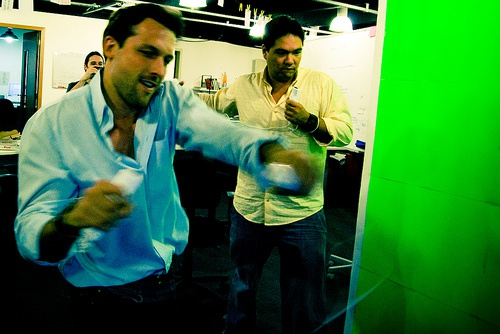Describe the objects in this image and their specific colors. I can see people in black, lightgreen, and teal tones, people in black, khaki, and olive tones, remote in black, beige, and teal tones, remote in black, darkgray, and teal tones, and people in black, tan, and olive tones in this image. 